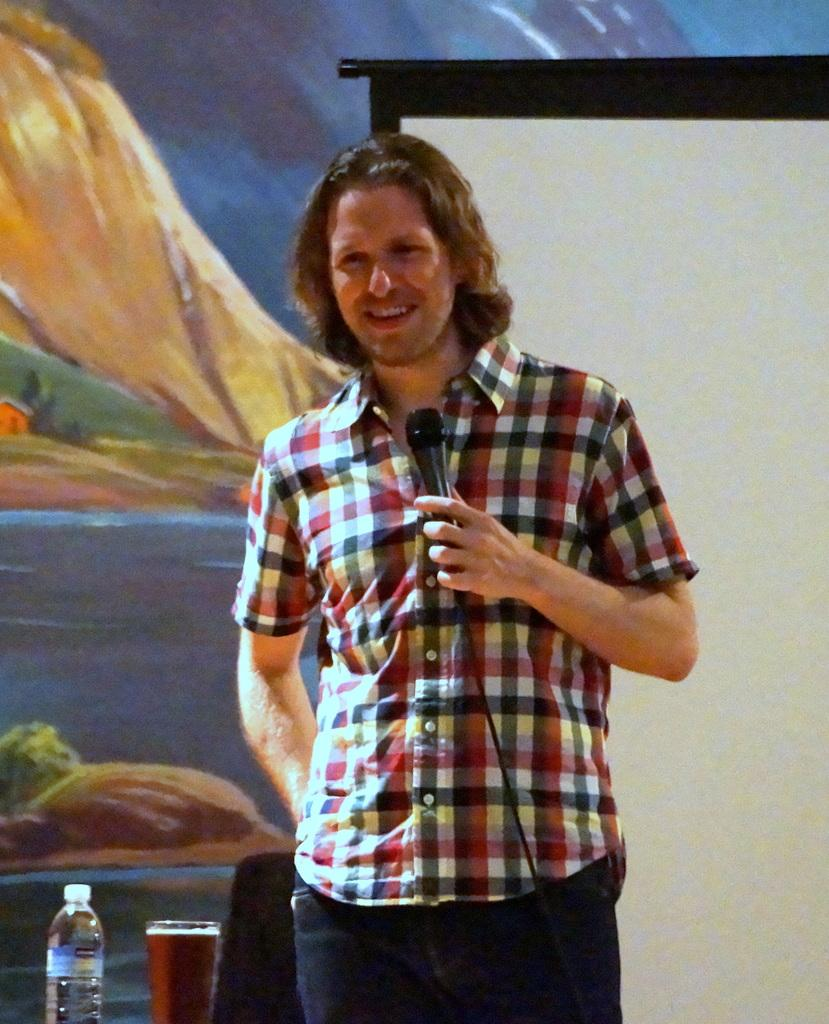What type of clothing is the person wearing in the image? The person is wearing blue jeans. What object is the person holding in their hand? The person is holding a microphone in their hand. What can be seen on the person's right side? There is a water bottle and a glass of drink on the person's right side. What can be seen in the background of the image? There is a projector in the background. Can you see a volleyball being played in the image? No, there is no volleyball or any indication of a game being played in the image. Is there a pump visible in the image? No, there is no pump present in the image. 